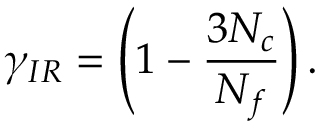Convert formula to latex. <formula><loc_0><loc_0><loc_500><loc_500>\gamma _ { I R } = \left ( 1 - \frac { 3 N _ { c } } { N _ { f } } \right ) .</formula> 